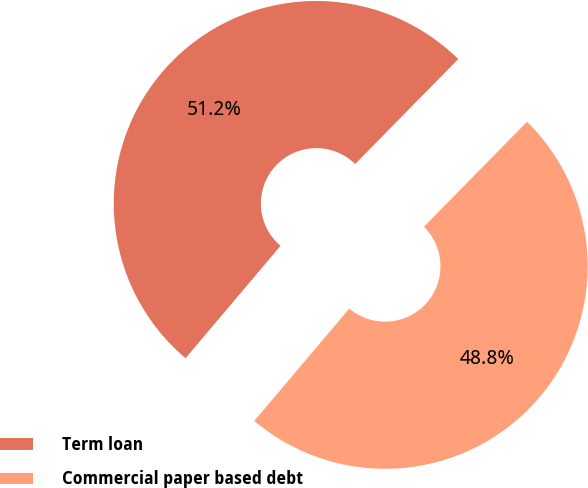Convert chart to OTSL. <chart><loc_0><loc_0><loc_500><loc_500><pie_chart><fcel>Term loan<fcel>Commercial paper based debt<nl><fcel>51.19%<fcel>48.81%<nl></chart> 